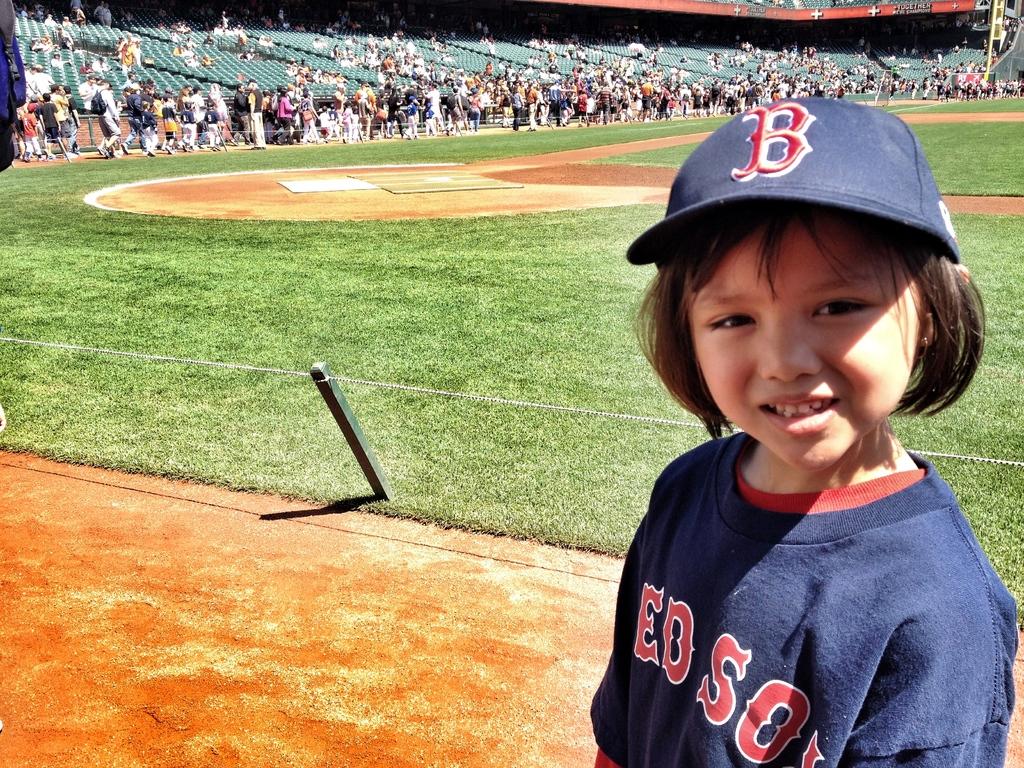What letter is on the kids hat?
Make the answer very short. B. What team name is on the child's shirt?
Your answer should be very brief. Red sox. 